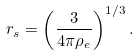Convert formula to latex. <formula><loc_0><loc_0><loc_500><loc_500>r _ { s } = \left ( \frac { 3 } { 4 \pi \rho _ { e } } \right ) ^ { 1 / 3 } .</formula> 